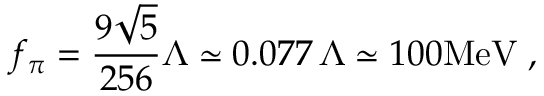<formula> <loc_0><loc_0><loc_500><loc_500>f _ { \pi } = \frac { 9 \sqrt { 5 } } { 2 5 6 } \Lambda \simeq 0 . 0 7 7 \, \Lambda \simeq 1 0 0 M e V \, ,</formula> 